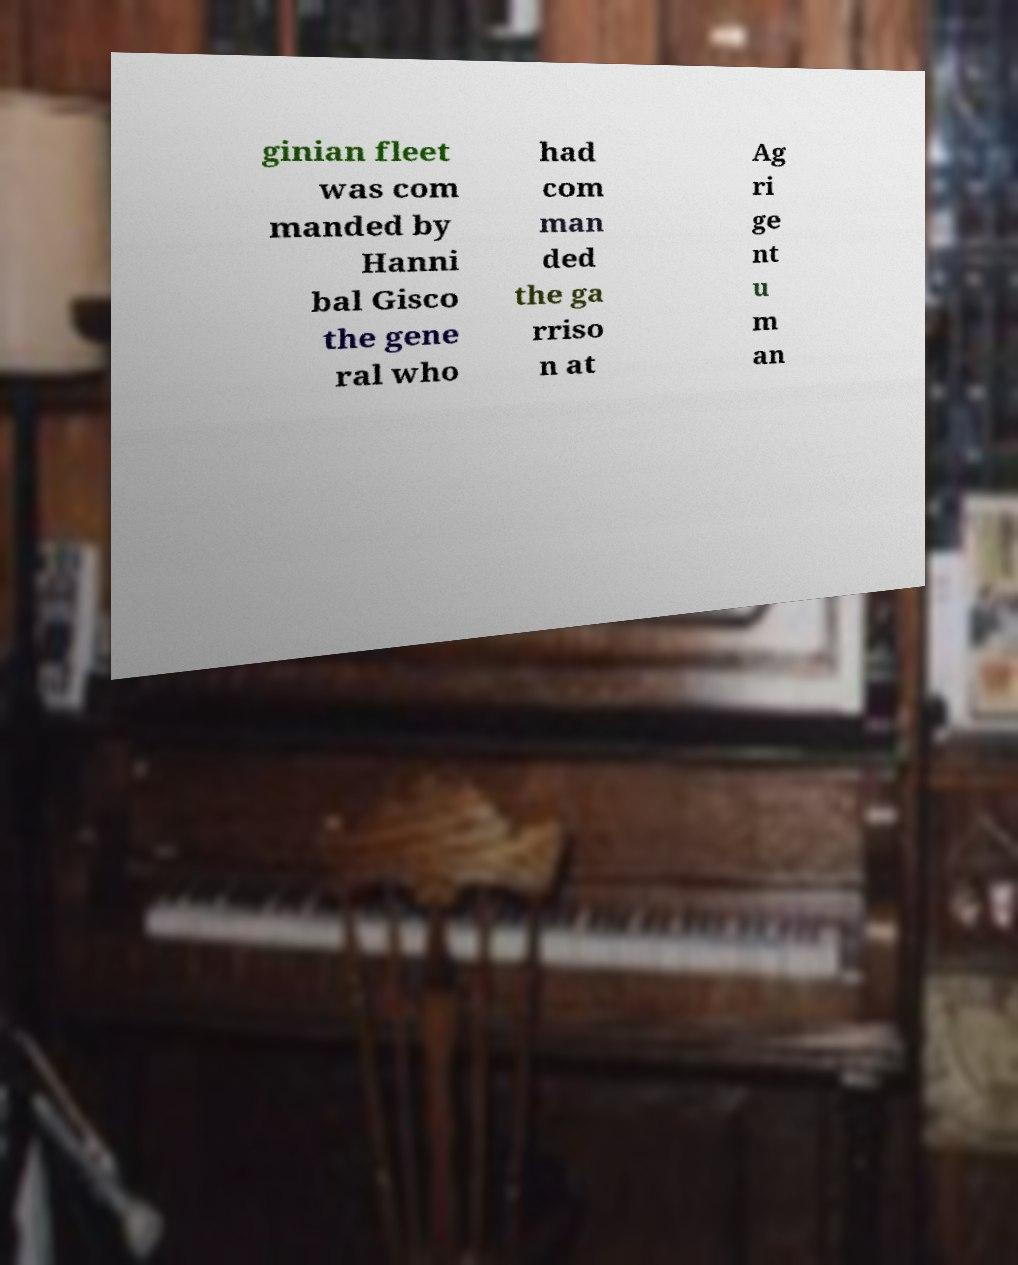Could you extract and type out the text from this image? ginian fleet was com manded by Hanni bal Gisco the gene ral who had com man ded the ga rriso n at Ag ri ge nt u m an 